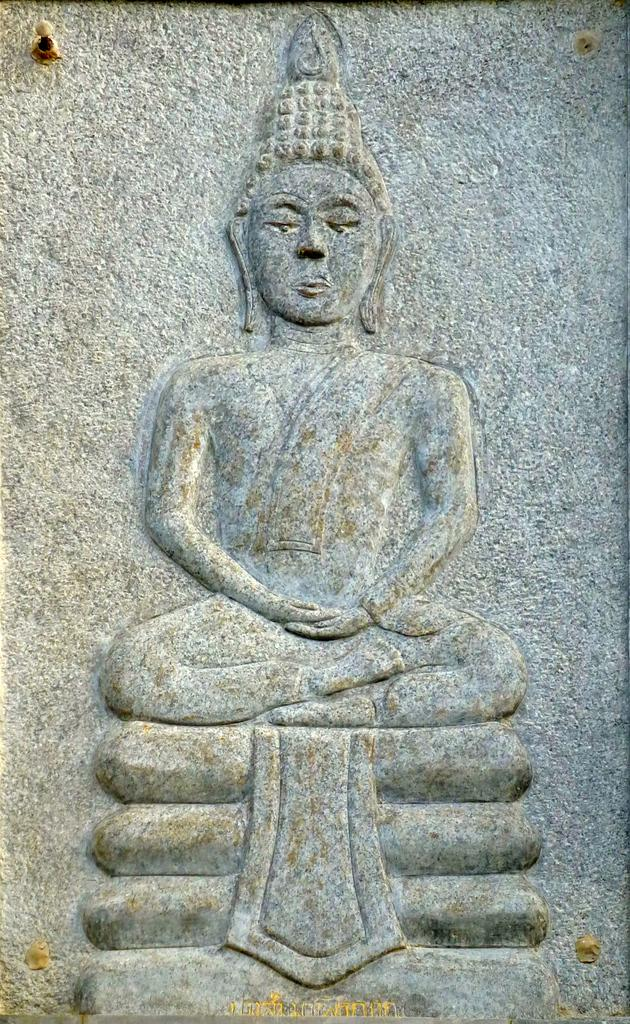What is on the wall in the image? There is a sculpture on the wall in the image. How many pigs are learning to play sticks in the image? There are no pigs or sticks present in the image, and therefore no such activity can be observed. 